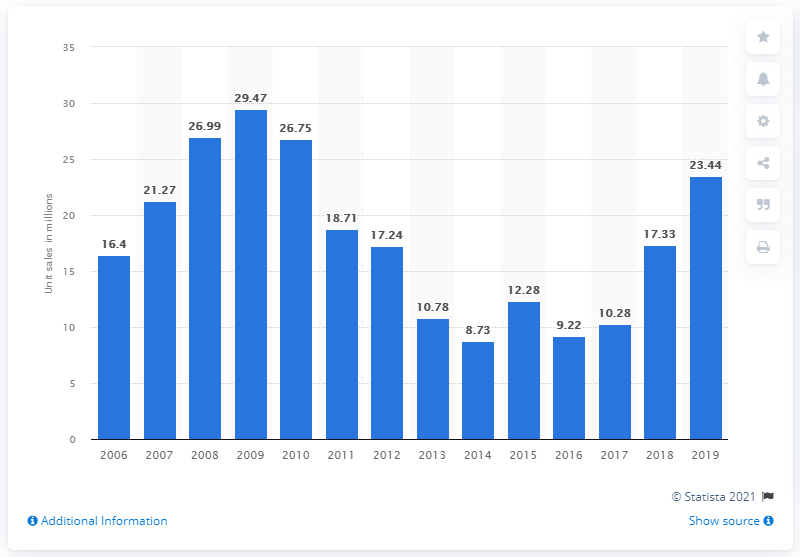Mention a couple of crucial points in this snapshot. Sega Sammy sold 17,330 copies of video games in the previous year. In 2006, Sega Sammy Holdings began selling video game software. In the last fiscal year of 2019, Sega Sammy sold a total of 23,440 copies of video games. 